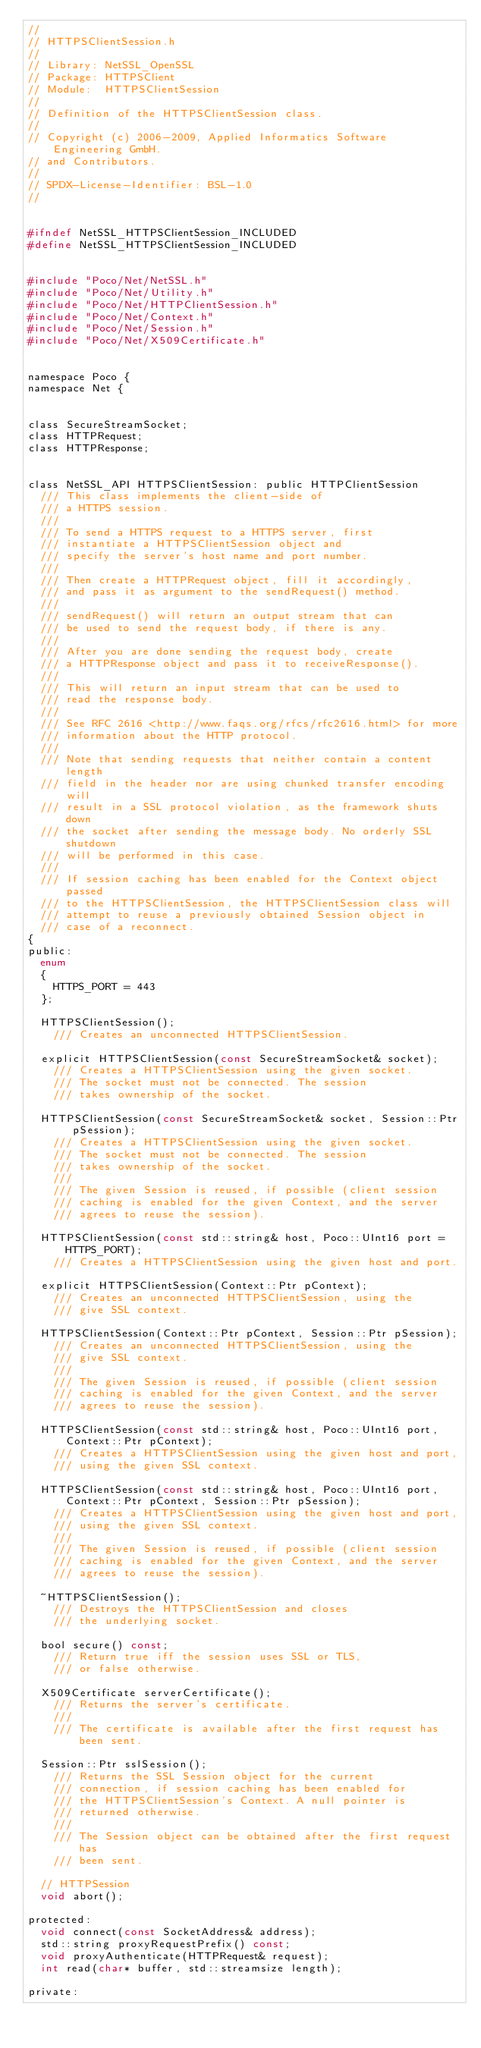Convert code to text. <code><loc_0><loc_0><loc_500><loc_500><_C_>//
// HTTPSClientSession.h
//
// Library: NetSSL_OpenSSL
// Package: HTTPSClient
// Module:  HTTPSClientSession
//
// Definition of the HTTPSClientSession class.
//
// Copyright (c) 2006-2009, Applied Informatics Software Engineering GmbH.
// and Contributors.
//
// SPDX-License-Identifier:	BSL-1.0
//


#ifndef NetSSL_HTTPSClientSession_INCLUDED
#define NetSSL_HTTPSClientSession_INCLUDED


#include "Poco/Net/NetSSL.h"
#include "Poco/Net/Utility.h"
#include "Poco/Net/HTTPClientSession.h"
#include "Poco/Net/Context.h"
#include "Poco/Net/Session.h"
#include "Poco/Net/X509Certificate.h"


namespace Poco {
namespace Net {


class SecureStreamSocket;
class HTTPRequest;
class HTTPResponse;


class NetSSL_API HTTPSClientSession: public HTTPClientSession
	/// This class implements the client-side of
	/// a HTTPS session.
	///
	/// To send a HTTPS request to a HTTPS server, first
	/// instantiate a HTTPSClientSession object and
	/// specify the server's host name and port number.
	///
	/// Then create a HTTPRequest object, fill it accordingly,
	/// and pass it as argument to the sendRequest() method.
	///
	/// sendRequest() will return an output stream that can
	/// be used to send the request body, if there is any.
	///
	/// After you are done sending the request body, create
	/// a HTTPResponse object and pass it to receiveResponse().
	///
	/// This will return an input stream that can be used to
	/// read the response body.
	///
	/// See RFC 2616 <http://www.faqs.org/rfcs/rfc2616.html> for more
	/// information about the HTTP protocol.
	///
	/// Note that sending requests that neither contain a content length
	/// field in the header nor are using chunked transfer encoding will
	/// result in a SSL protocol violation, as the framework shuts down
	/// the socket after sending the message body. No orderly SSL shutdown
	/// will be performed in this case.
	///
	/// If session caching has been enabled for the Context object passed
	/// to the HTTPSClientSession, the HTTPSClientSession class will
	/// attempt to reuse a previously obtained Session object in
	/// case of a reconnect.
{
public:
	enum
	{
		HTTPS_PORT = 443
	};
	
	HTTPSClientSession();
		/// Creates an unconnected HTTPSClientSession.

	explicit HTTPSClientSession(const SecureStreamSocket& socket);
		/// Creates a HTTPSClientSession using the given socket.
		/// The socket must not be connected. The session
		/// takes ownership of the socket.

	HTTPSClientSession(const SecureStreamSocket& socket, Session::Ptr pSession);
		/// Creates a HTTPSClientSession using the given socket.
		/// The socket must not be connected. The session
		/// takes ownership of the socket.
		///
		/// The given Session is reused, if possible (client session
		/// caching is enabled for the given Context, and the server
		/// agrees to reuse the session).

	HTTPSClientSession(const std::string& host, Poco::UInt16 port = HTTPS_PORT);
		/// Creates a HTTPSClientSession using the given host and port.

	explicit HTTPSClientSession(Context::Ptr pContext);
		/// Creates an unconnected HTTPSClientSession, using the
		/// give SSL context.

	HTTPSClientSession(Context::Ptr pContext, Session::Ptr pSession);
		/// Creates an unconnected HTTPSClientSession, using the
		/// give SSL context.
		///
		/// The given Session is reused, if possible (client session
		/// caching is enabled for the given Context, and the server
		/// agrees to reuse the session).

	HTTPSClientSession(const std::string& host, Poco::UInt16 port, Context::Ptr pContext);
		/// Creates a HTTPSClientSession using the given host and port,
		/// using the given SSL context.

	HTTPSClientSession(const std::string& host, Poco::UInt16 port, Context::Ptr pContext, Session::Ptr pSession);
		/// Creates a HTTPSClientSession using the given host and port,
		/// using the given SSL context.
		///
		/// The given Session is reused, if possible (client session
		/// caching is enabled for the given Context, and the server
		/// agrees to reuse the session).

	~HTTPSClientSession();
		/// Destroys the HTTPSClientSession and closes
		/// the underlying socket.
	
	bool secure() const;
		/// Return true iff the session uses SSL or TLS,
		/// or false otherwise.
		
	X509Certificate serverCertificate();
		/// Returns the server's certificate.
		///
		/// The certificate is available after the first request has been sent.
		
	Session::Ptr sslSession();
		/// Returns the SSL Session object for the current 
		/// connection, if session caching has been enabled for
		/// the HTTPSClientSession's Context. A null pointer is 
		/// returned otherwise.
		///
		/// The Session object can be obtained after the first request has
		/// been sent.
		
	// HTTPSession
	void abort();

protected:
	void connect(const SocketAddress& address);
	std::string proxyRequestPrefix() const;
	void proxyAuthenticate(HTTPRequest& request);
	int read(char* buffer, std::streamsize length);

private:</code> 